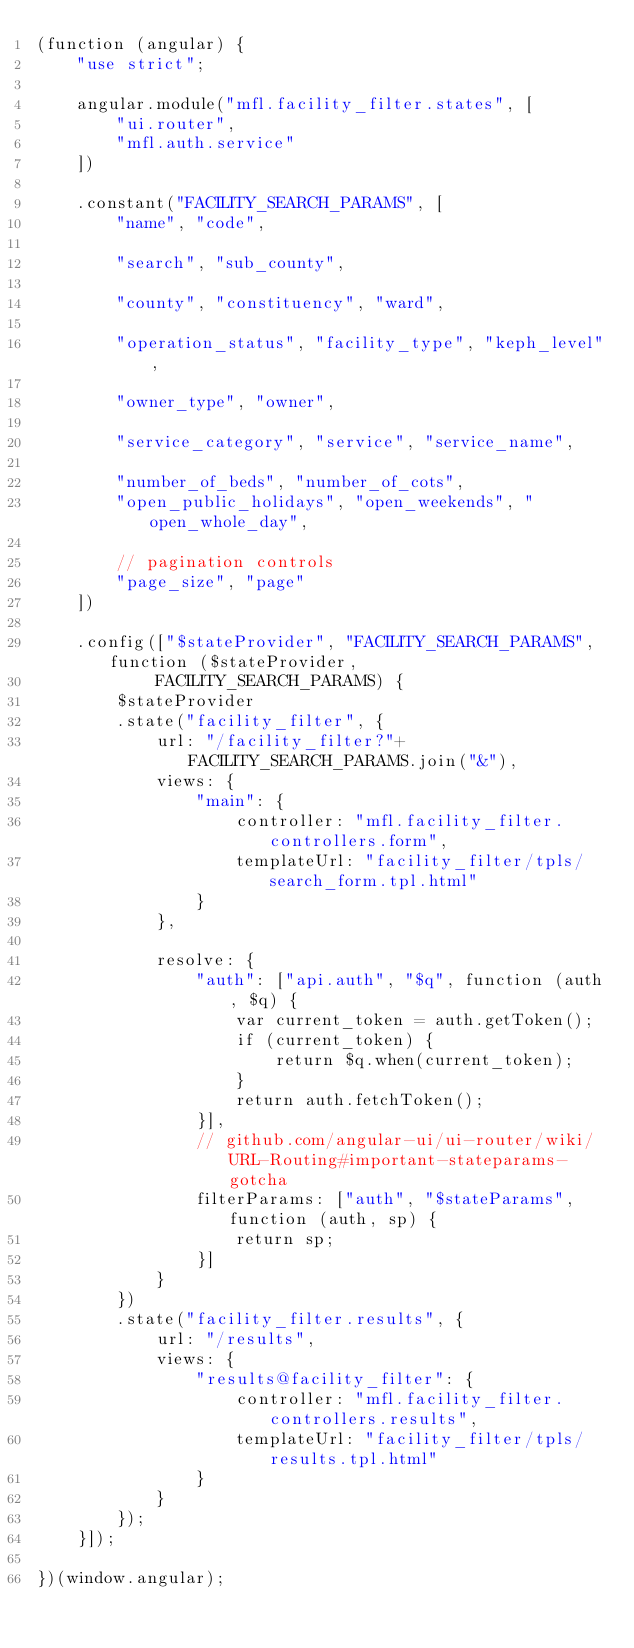<code> <loc_0><loc_0><loc_500><loc_500><_JavaScript_>(function (angular) {
    "use strict";

    angular.module("mfl.facility_filter.states", [
        "ui.router",
        "mfl.auth.service"
    ])

    .constant("FACILITY_SEARCH_PARAMS", [
        "name", "code",

        "search", "sub_county",

        "county", "constituency", "ward",

        "operation_status", "facility_type", "keph_level",

        "owner_type", "owner",

        "service_category", "service", "service_name",

        "number_of_beds", "number_of_cots",
        "open_public_holidays", "open_weekends", "open_whole_day",

        // pagination controls
        "page_size", "page"
    ])

    .config(["$stateProvider", "FACILITY_SEARCH_PARAMS", function ($stateProvider,
            FACILITY_SEARCH_PARAMS) {
        $stateProvider
        .state("facility_filter", {
            url: "/facility_filter?"+FACILITY_SEARCH_PARAMS.join("&"),
            views: {
                "main": {
                    controller: "mfl.facility_filter.controllers.form",
                    templateUrl: "facility_filter/tpls/search_form.tpl.html"
                }
            },

            resolve: {
                "auth": ["api.auth", "$q", function (auth, $q) {
                    var current_token = auth.getToken();
                    if (current_token) {
                        return $q.when(current_token);
                    }
                    return auth.fetchToken();
                }],
                // github.com/angular-ui/ui-router/wiki/URL-Routing#important-stateparams-gotcha
                filterParams: ["auth", "$stateParams", function (auth, sp) {
                    return sp;
                }]
            }
        })
        .state("facility_filter.results", {
            url: "/results",
            views: {
                "results@facility_filter": {
                    controller: "mfl.facility_filter.controllers.results",
                    templateUrl: "facility_filter/tpls/results.tpl.html"
                }
            }
        });
    }]);

})(window.angular);
</code> 